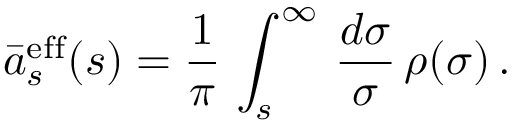<formula> <loc_0><loc_0><loc_500><loc_500>\bar { a } _ { s } ^ { e f f } ( s ) = \frac { 1 } { \pi } \, \int _ { s } ^ { \infty } \, \frac { d \sigma } { \sigma } \, \rho ( \sigma ) \, .</formula> 